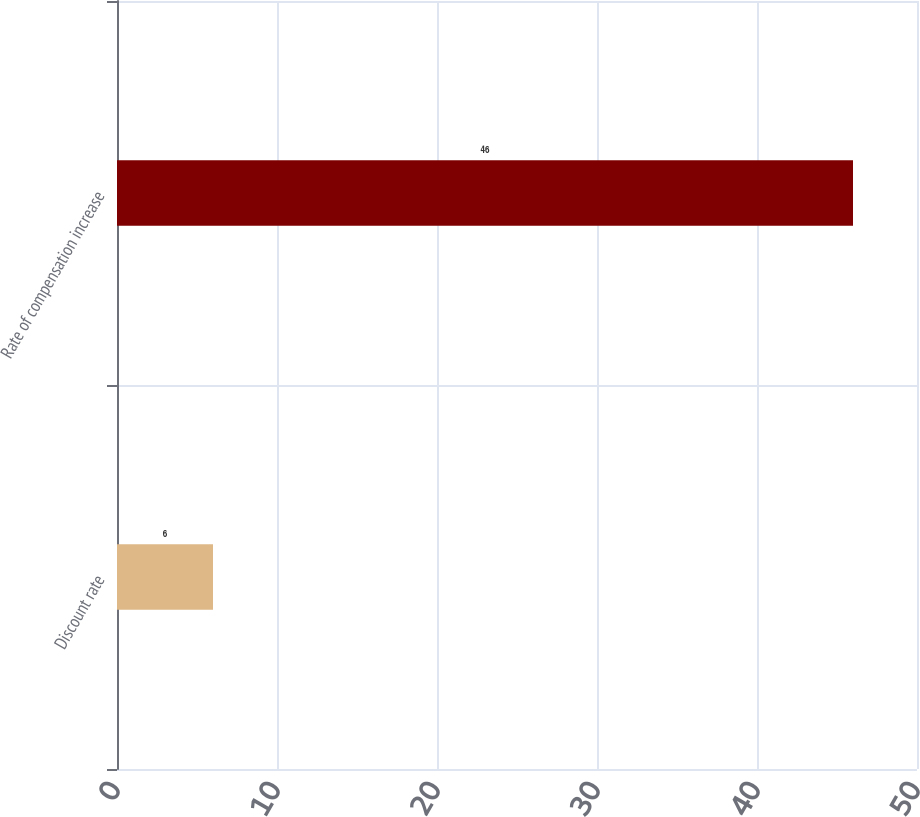<chart> <loc_0><loc_0><loc_500><loc_500><bar_chart><fcel>Discount rate<fcel>Rate of compensation increase<nl><fcel>6<fcel>46<nl></chart> 